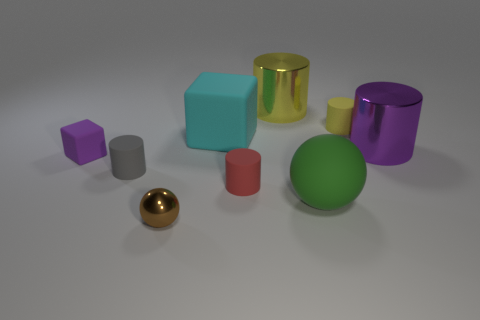Subtract all green cylinders. Subtract all yellow cubes. How many cylinders are left? 5 Subtract all cylinders. How many objects are left? 4 Add 5 cyan matte things. How many cyan matte things exist? 6 Subtract 0 gray spheres. How many objects are left? 9 Subtract all purple matte balls. Subtract all metallic spheres. How many objects are left? 8 Add 3 brown spheres. How many brown spheres are left? 4 